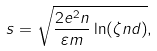Convert formula to latex. <formula><loc_0><loc_0><loc_500><loc_500>s = \sqrt { \frac { 2 e ^ { 2 } n } { \varepsilon m } \ln ( \zeta n d ) } ,</formula> 